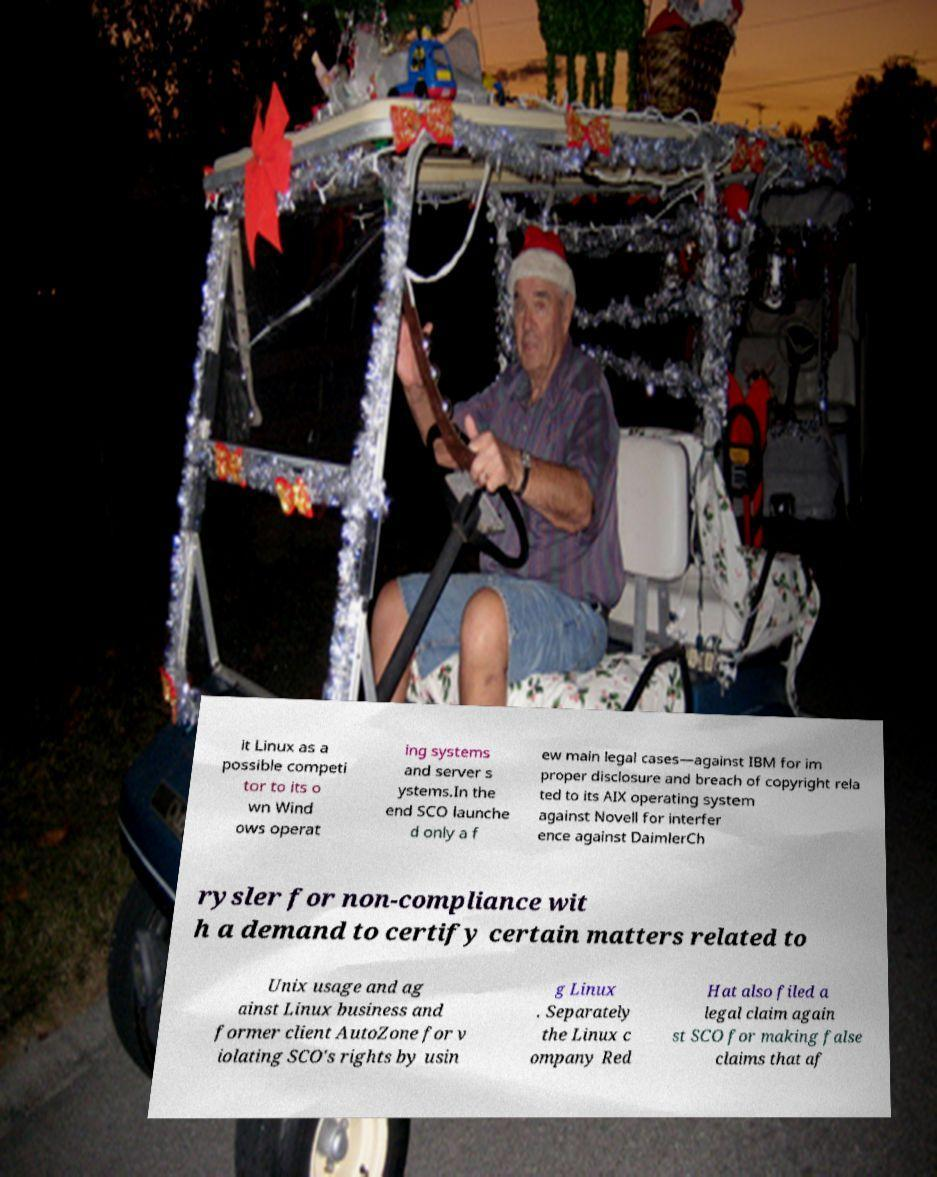Please read and relay the text visible in this image. What does it say? it Linux as a possible competi tor to its o wn Wind ows operat ing systems and server s ystems.In the end SCO launche d only a f ew main legal cases—against IBM for im proper disclosure and breach of copyright rela ted to its AIX operating system against Novell for interfer ence against DaimlerCh rysler for non-compliance wit h a demand to certify certain matters related to Unix usage and ag ainst Linux business and former client AutoZone for v iolating SCO's rights by usin g Linux . Separately the Linux c ompany Red Hat also filed a legal claim again st SCO for making false claims that af 